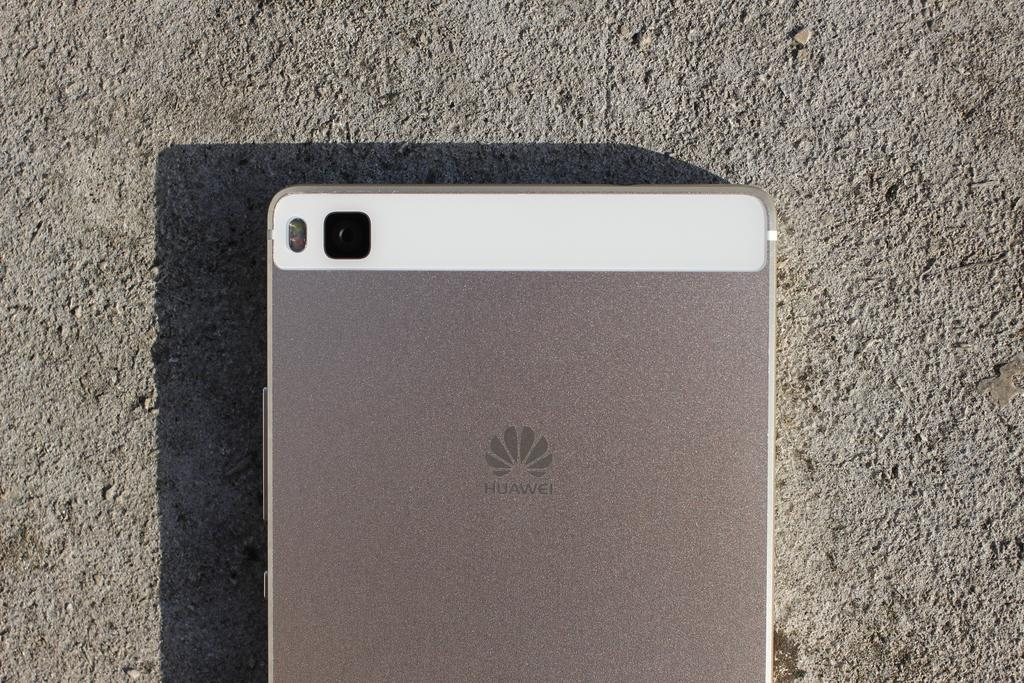Provide a one-sentence caption for the provided image. A Huawei phone has a small square camera lens on the back of it. 